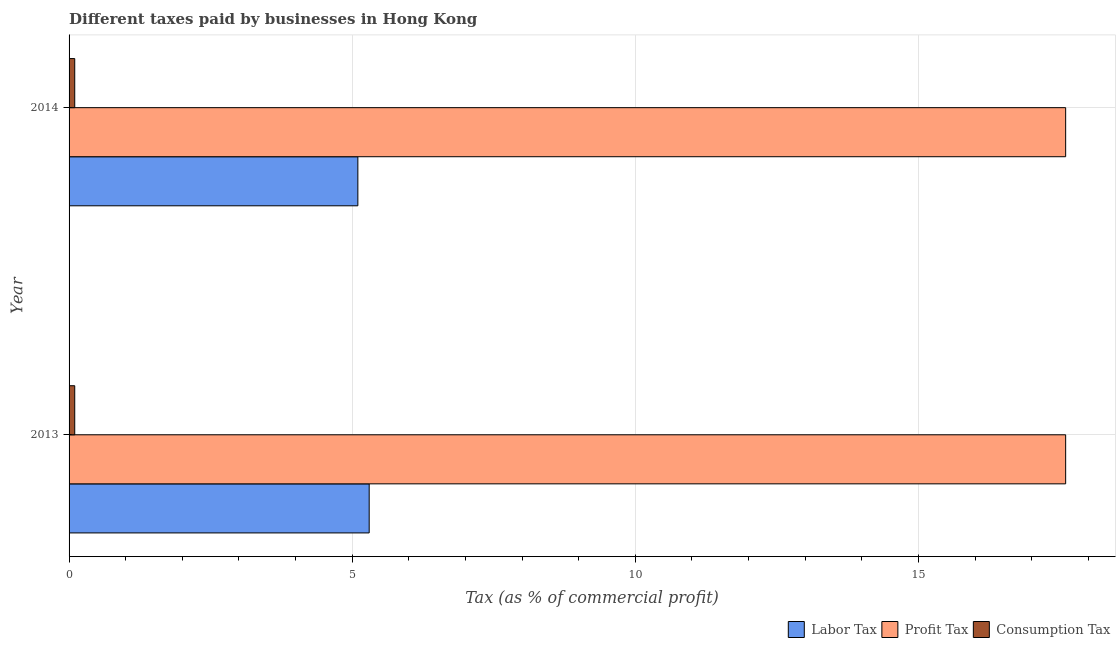How many different coloured bars are there?
Your answer should be compact. 3. How many groups of bars are there?
Provide a short and direct response. 2. How many bars are there on the 2nd tick from the bottom?
Ensure brevity in your answer.  3. What is the label of the 1st group of bars from the top?
Offer a terse response. 2014. What is the percentage of labor tax in 2014?
Make the answer very short. 5.1. Across all years, what is the maximum percentage of consumption tax?
Keep it short and to the point. 0.1. In which year was the percentage of consumption tax maximum?
Offer a terse response. 2013. What is the difference between the percentage of consumption tax in 2013 and the percentage of labor tax in 2014?
Give a very brief answer. -5. In the year 2013, what is the difference between the percentage of consumption tax and percentage of labor tax?
Provide a succinct answer. -5.2. What is the ratio of the percentage of profit tax in 2013 to that in 2014?
Your answer should be compact. 1. Is the percentage of consumption tax in 2013 less than that in 2014?
Provide a short and direct response. No. Is the difference between the percentage of consumption tax in 2013 and 2014 greater than the difference between the percentage of labor tax in 2013 and 2014?
Ensure brevity in your answer.  No. What does the 2nd bar from the top in 2014 represents?
Your answer should be very brief. Profit Tax. What does the 1st bar from the bottom in 2013 represents?
Offer a terse response. Labor Tax. Is it the case that in every year, the sum of the percentage of labor tax and percentage of profit tax is greater than the percentage of consumption tax?
Offer a very short reply. Yes. How many bars are there?
Provide a succinct answer. 6. Are the values on the major ticks of X-axis written in scientific E-notation?
Keep it short and to the point. No. Does the graph contain any zero values?
Keep it short and to the point. No. Where does the legend appear in the graph?
Provide a succinct answer. Bottom right. What is the title of the graph?
Ensure brevity in your answer.  Different taxes paid by businesses in Hong Kong. What is the label or title of the X-axis?
Your answer should be very brief. Tax (as % of commercial profit). What is the Tax (as % of commercial profit) of Labor Tax in 2013?
Provide a short and direct response. 5.3. What is the Tax (as % of commercial profit) of Profit Tax in 2013?
Your response must be concise. 17.6. What is the Tax (as % of commercial profit) in Labor Tax in 2014?
Ensure brevity in your answer.  5.1. What is the Tax (as % of commercial profit) of Profit Tax in 2014?
Your answer should be compact. 17.6. Across all years, what is the maximum Tax (as % of commercial profit) of Consumption Tax?
Your response must be concise. 0.1. Across all years, what is the minimum Tax (as % of commercial profit) of Consumption Tax?
Offer a terse response. 0.1. What is the total Tax (as % of commercial profit) in Labor Tax in the graph?
Provide a short and direct response. 10.4. What is the total Tax (as % of commercial profit) of Profit Tax in the graph?
Ensure brevity in your answer.  35.2. What is the total Tax (as % of commercial profit) in Consumption Tax in the graph?
Keep it short and to the point. 0.2. What is the difference between the Tax (as % of commercial profit) of Labor Tax in 2013 and that in 2014?
Provide a succinct answer. 0.2. What is the difference between the Tax (as % of commercial profit) of Labor Tax in 2013 and the Tax (as % of commercial profit) of Profit Tax in 2014?
Your answer should be compact. -12.3. What is the difference between the Tax (as % of commercial profit) of Profit Tax in 2013 and the Tax (as % of commercial profit) of Consumption Tax in 2014?
Your response must be concise. 17.5. What is the average Tax (as % of commercial profit) in Labor Tax per year?
Keep it short and to the point. 5.2. What is the average Tax (as % of commercial profit) in Consumption Tax per year?
Offer a terse response. 0.1. In the year 2013, what is the difference between the Tax (as % of commercial profit) of Labor Tax and Tax (as % of commercial profit) of Profit Tax?
Your response must be concise. -12.3. In the year 2013, what is the difference between the Tax (as % of commercial profit) in Labor Tax and Tax (as % of commercial profit) in Consumption Tax?
Offer a very short reply. 5.2. In the year 2014, what is the difference between the Tax (as % of commercial profit) of Labor Tax and Tax (as % of commercial profit) of Profit Tax?
Provide a succinct answer. -12.5. What is the ratio of the Tax (as % of commercial profit) in Labor Tax in 2013 to that in 2014?
Offer a terse response. 1.04. What is the ratio of the Tax (as % of commercial profit) in Consumption Tax in 2013 to that in 2014?
Your answer should be very brief. 1. What is the difference between the highest and the second highest Tax (as % of commercial profit) of Labor Tax?
Offer a very short reply. 0.2. What is the difference between the highest and the second highest Tax (as % of commercial profit) of Profit Tax?
Ensure brevity in your answer.  0. What is the difference between the highest and the second highest Tax (as % of commercial profit) in Consumption Tax?
Give a very brief answer. 0. 